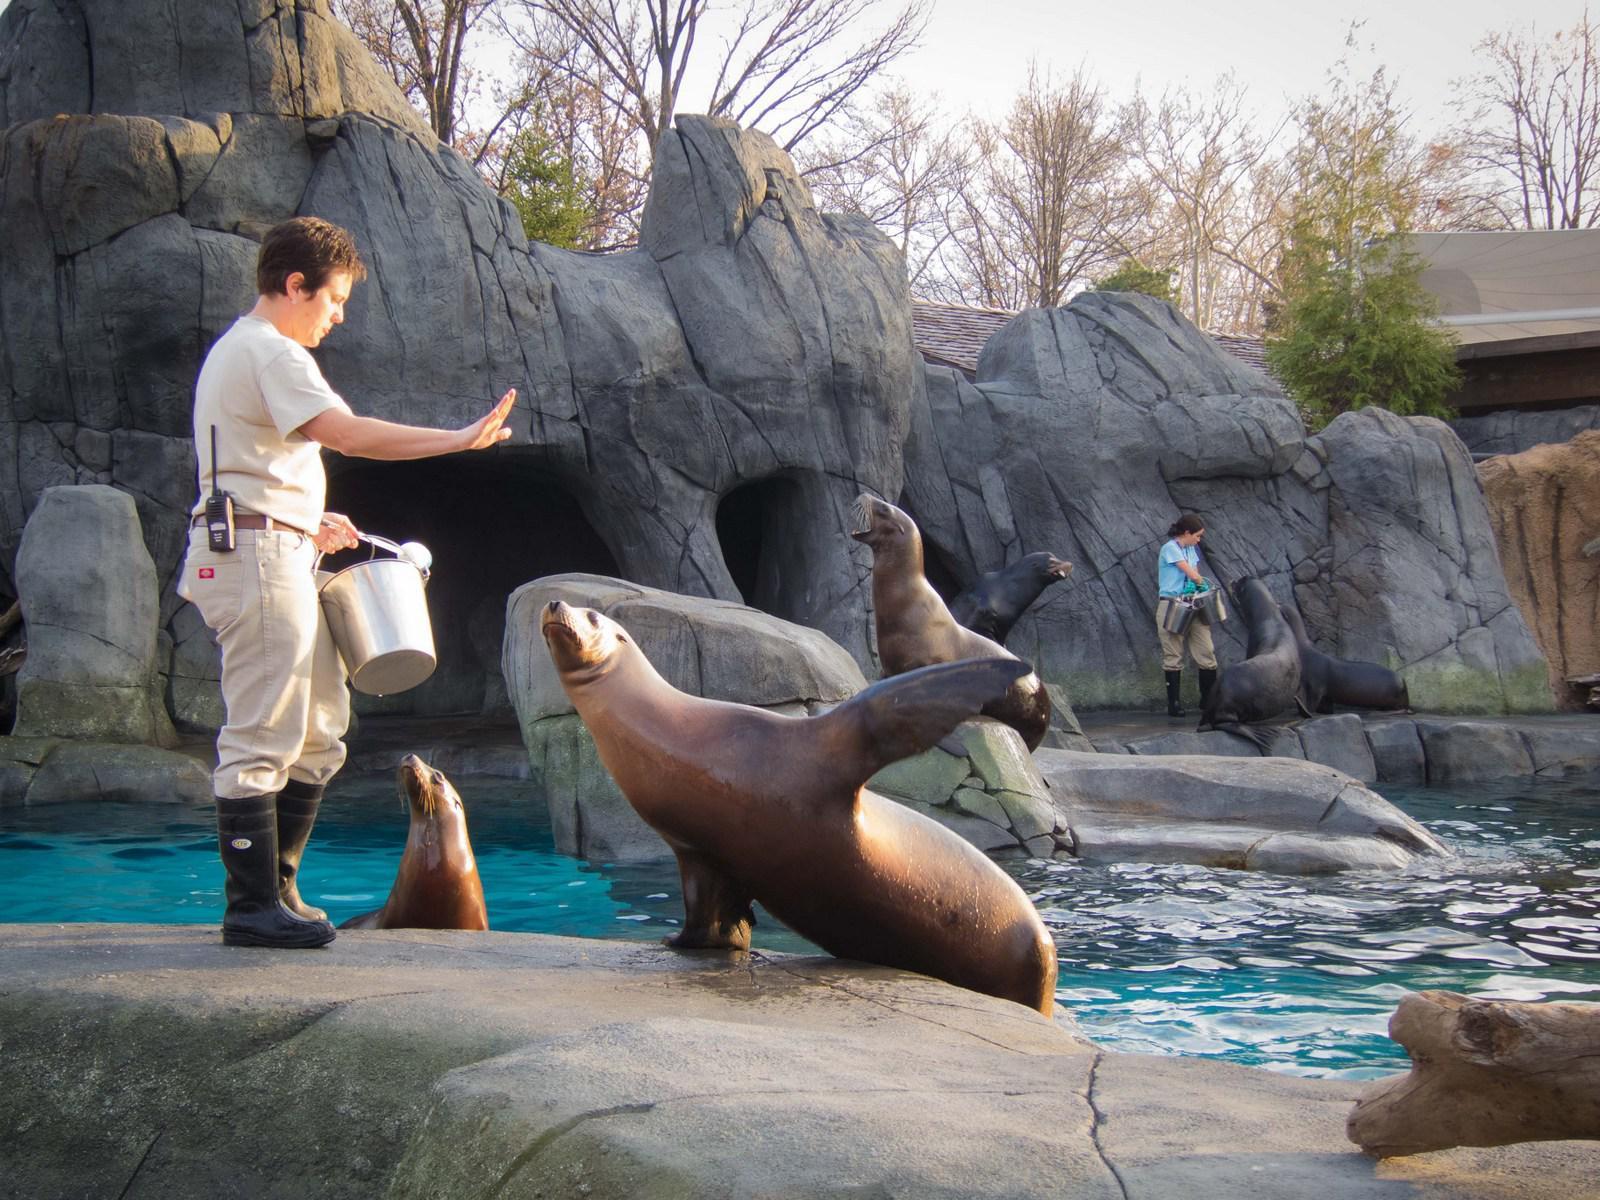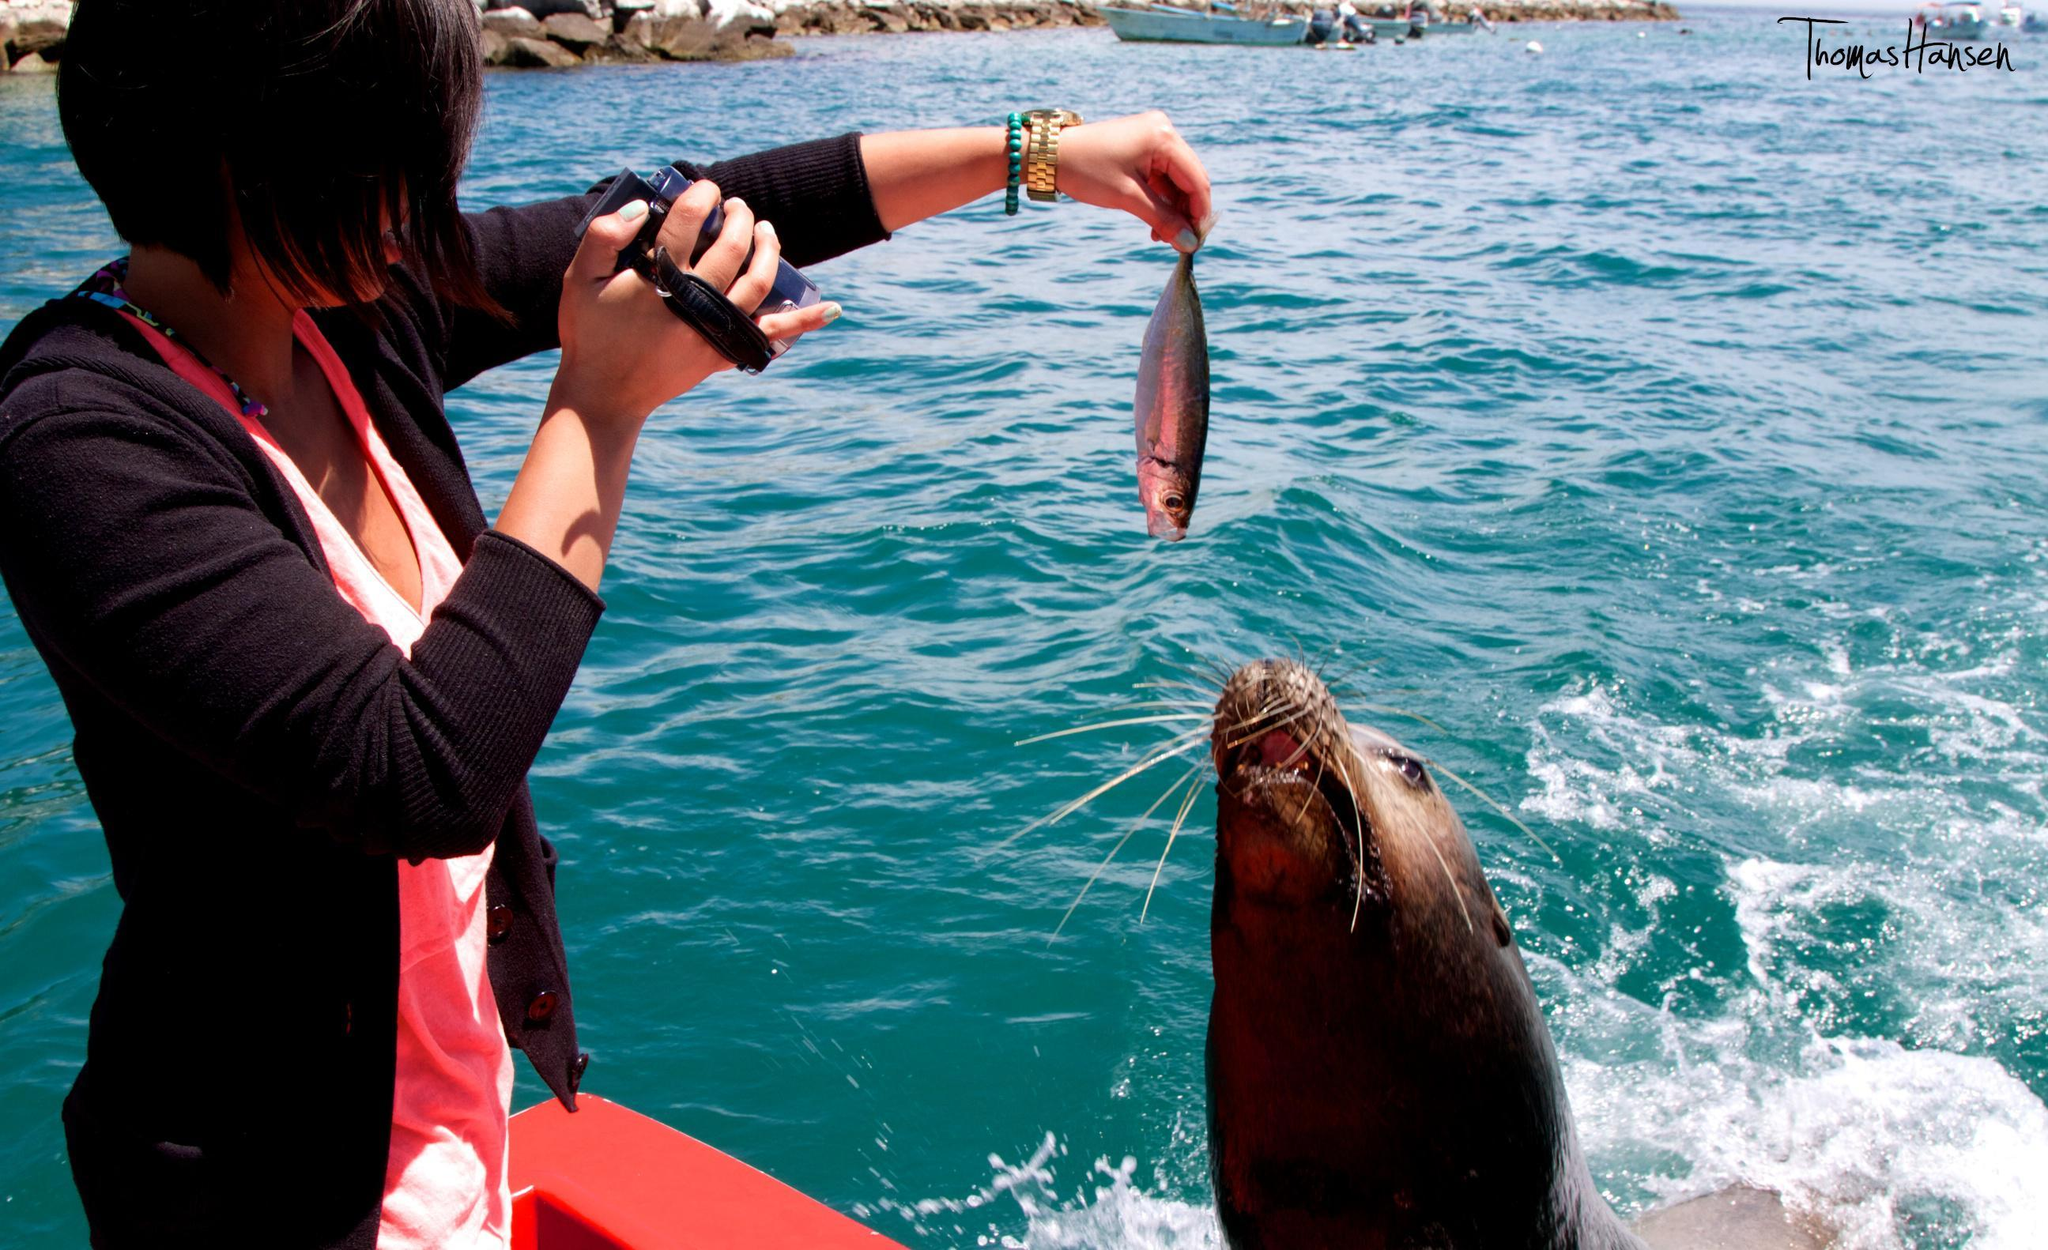The first image is the image on the left, the second image is the image on the right. Analyze the images presented: Is the assertion "A sea lion is looking over a boat where a woman sits." valid? Answer yes or no. No. The first image is the image on the left, the second image is the image on the right. For the images displayed, is the sentence "The right image contains a person holding a fish." factually correct? Answer yes or no. Yes. 